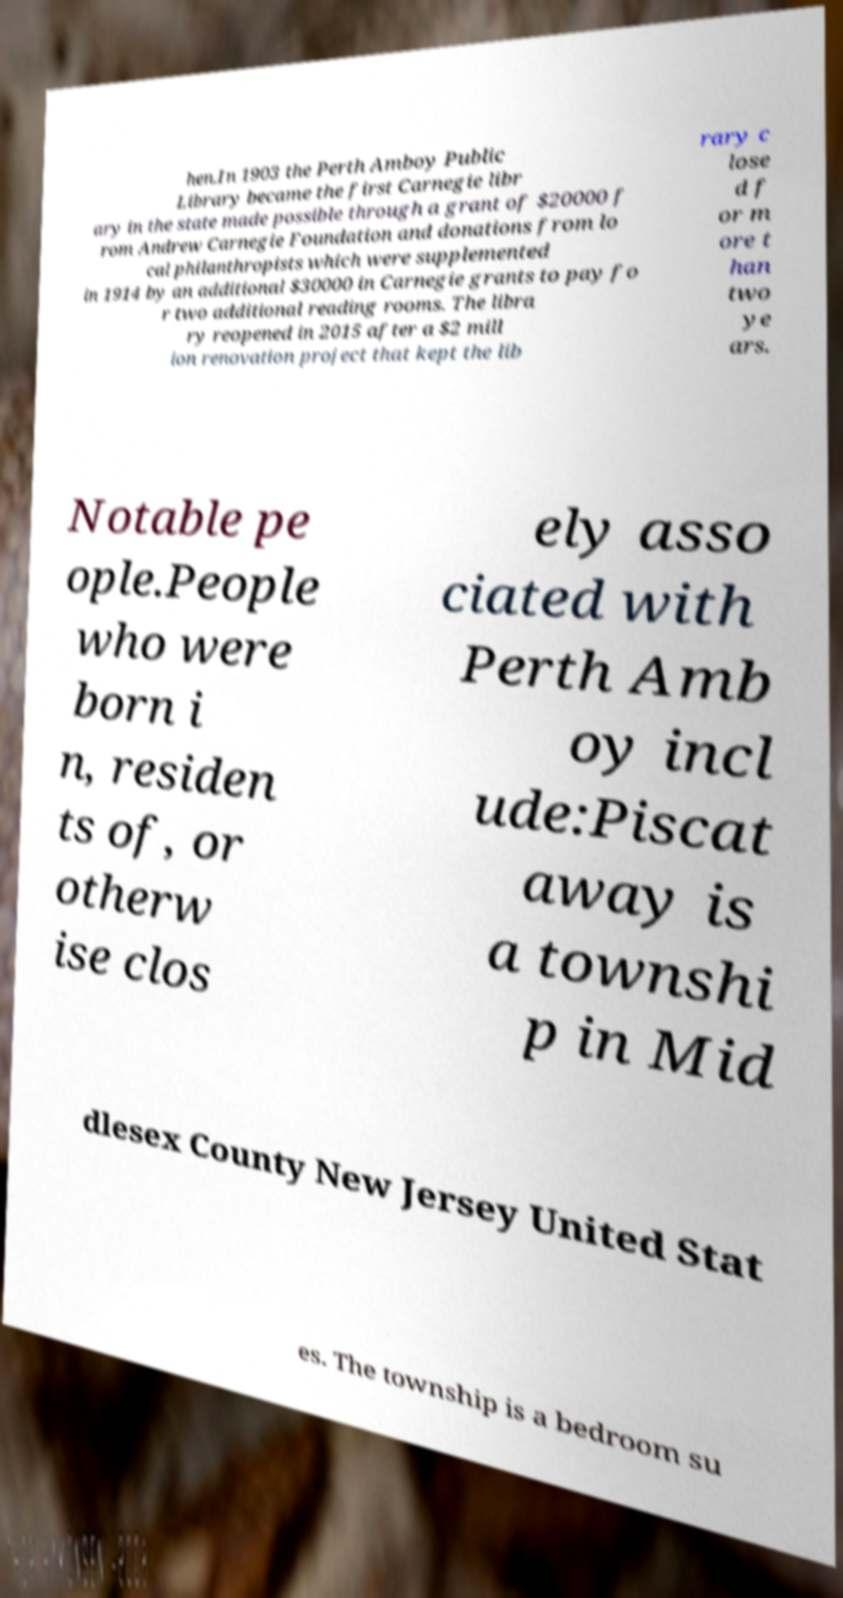Could you extract and type out the text from this image? hen.In 1903 the Perth Amboy Public Library became the first Carnegie libr ary in the state made possible through a grant of $20000 f rom Andrew Carnegie Foundation and donations from lo cal philanthropists which were supplemented in 1914 by an additional $30000 in Carnegie grants to pay fo r two additional reading rooms. The libra ry reopened in 2015 after a $2 mill ion renovation project that kept the lib rary c lose d f or m ore t han two ye ars. Notable pe ople.People who were born i n, residen ts of, or otherw ise clos ely asso ciated with Perth Amb oy incl ude:Piscat away is a townshi p in Mid dlesex County New Jersey United Stat es. The township is a bedroom su 